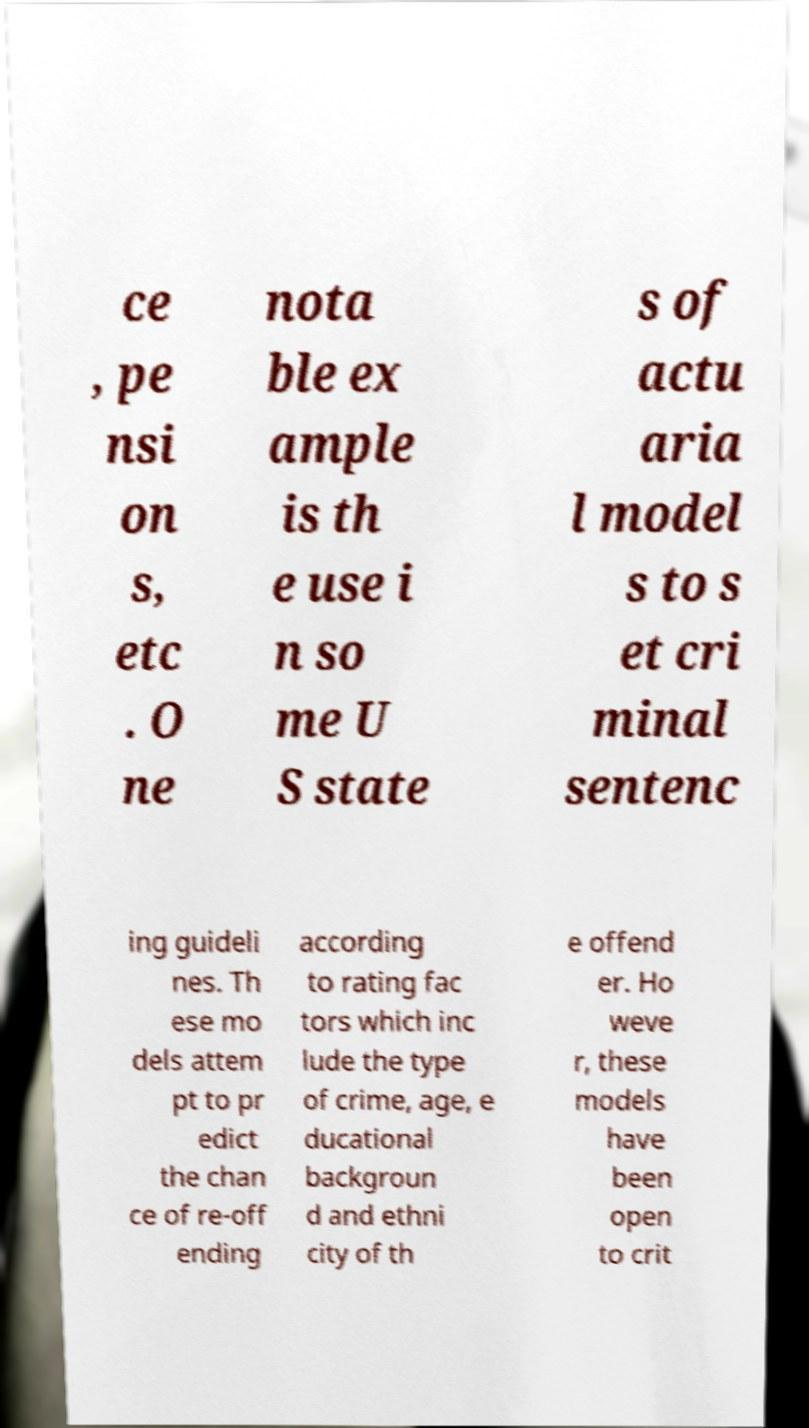I need the written content from this picture converted into text. Can you do that? ce , pe nsi on s, etc . O ne nota ble ex ample is th e use i n so me U S state s of actu aria l model s to s et cri minal sentenc ing guideli nes. Th ese mo dels attem pt to pr edict the chan ce of re-off ending according to rating fac tors which inc lude the type of crime, age, e ducational backgroun d and ethni city of th e offend er. Ho weve r, these models have been open to crit 